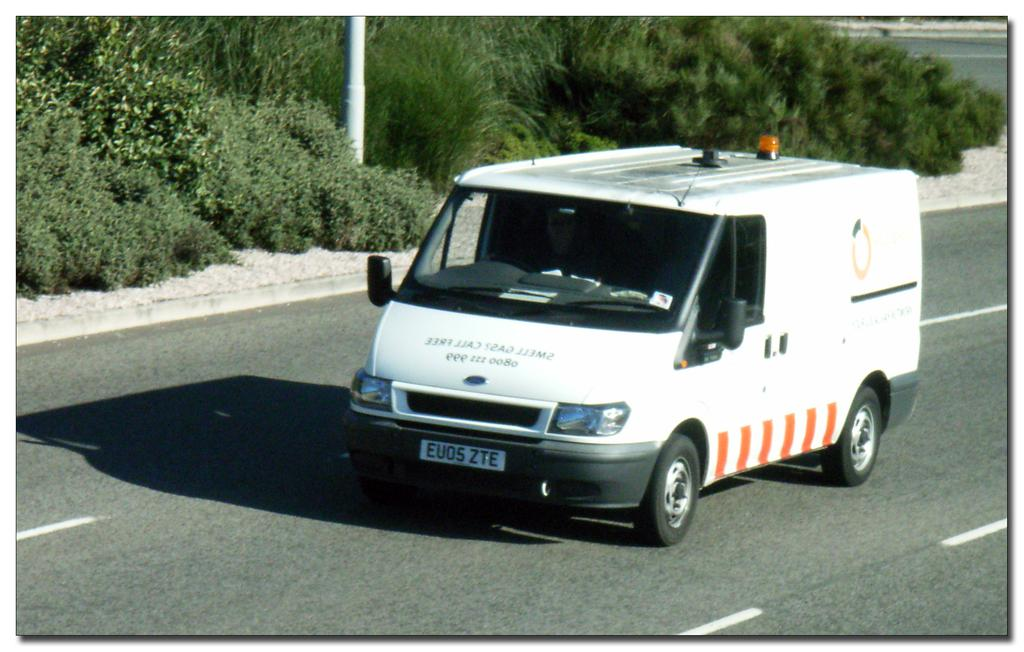<image>
Write a terse but informative summary of the picture. White ambulance on the street with the license pltae EU05ZTE. 